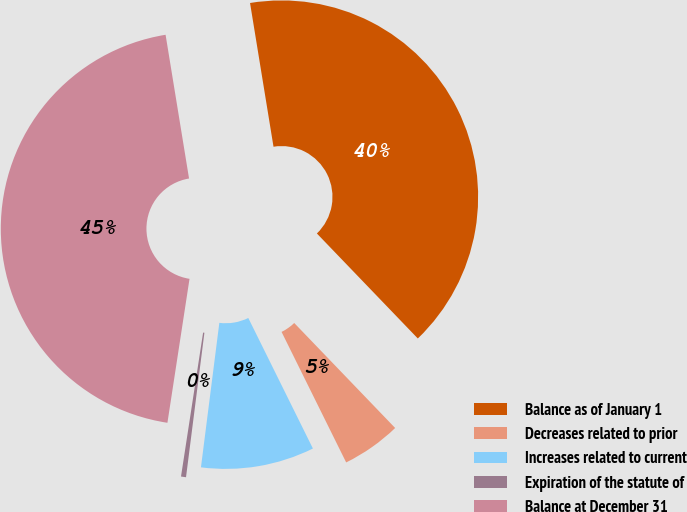Convert chart. <chart><loc_0><loc_0><loc_500><loc_500><pie_chart><fcel>Balance as of January 1<fcel>Decreases related to prior<fcel>Increases related to current<fcel>Expiration of the statute of<fcel>Balance at December 31<nl><fcel>40.39%<fcel>4.87%<fcel>9.33%<fcel>0.41%<fcel>45.0%<nl></chart> 